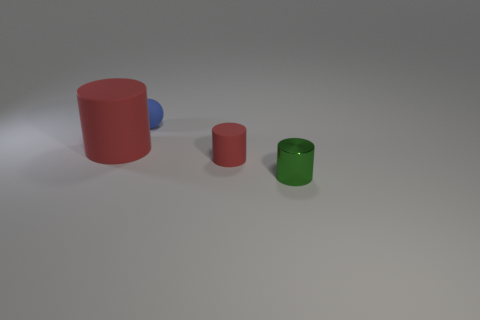What number of things have the same color as the large cylinder?
Your answer should be very brief. 1. What material is the small cylinder that is the same color as the large cylinder?
Provide a short and direct response. Rubber. What size is the other cylinder that is the same color as the small matte cylinder?
Provide a short and direct response. Large. What material is the red cylinder that is in front of the cylinder behind the tiny cylinder that is behind the small shiny thing made of?
Offer a terse response. Rubber. Are there any other matte cylinders that have the same color as the small matte cylinder?
Offer a very short reply. Yes. Are there fewer small shiny things left of the small green metal cylinder than small green objects?
Offer a terse response. Yes. Do the red rubber cylinder that is to the left of the matte sphere and the green metallic cylinder have the same size?
Provide a succinct answer. No. What number of cylinders are both behind the green thing and on the right side of the blue sphere?
Offer a very short reply. 1. How big is the red matte cylinder left of the small cylinder behind the green metal thing?
Provide a succinct answer. Large. Are there fewer large red matte cylinders to the right of the small red cylinder than large matte objects in front of the big cylinder?
Keep it short and to the point. No. 